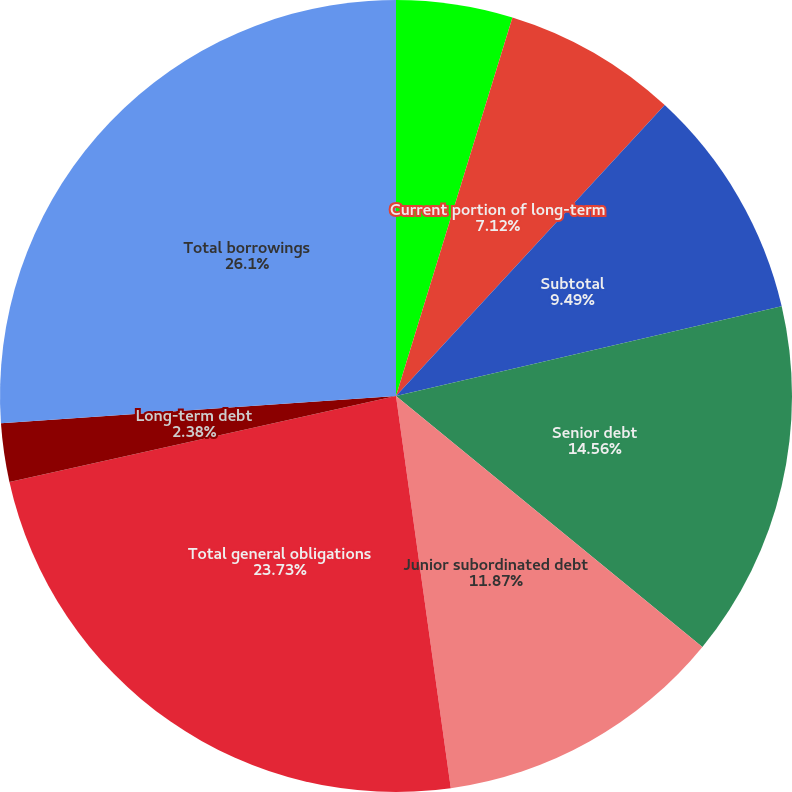Convert chart. <chart><loc_0><loc_0><loc_500><loc_500><pie_chart><fcel>Commercial paper<fcel>Current portion of long-term<fcel>Subtotal<fcel>Senior debt<fcel>Junior subordinated debt<fcel>Surplus notes(2)<fcel>Total general obligations<fcel>Long-term debt<fcel>Total borrowings<nl><fcel>4.75%<fcel>7.12%<fcel>9.49%<fcel>14.56%<fcel>11.87%<fcel>0.0%<fcel>23.73%<fcel>2.38%<fcel>26.1%<nl></chart> 